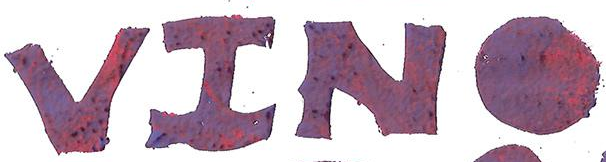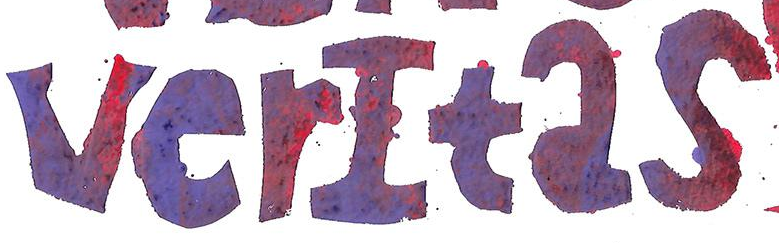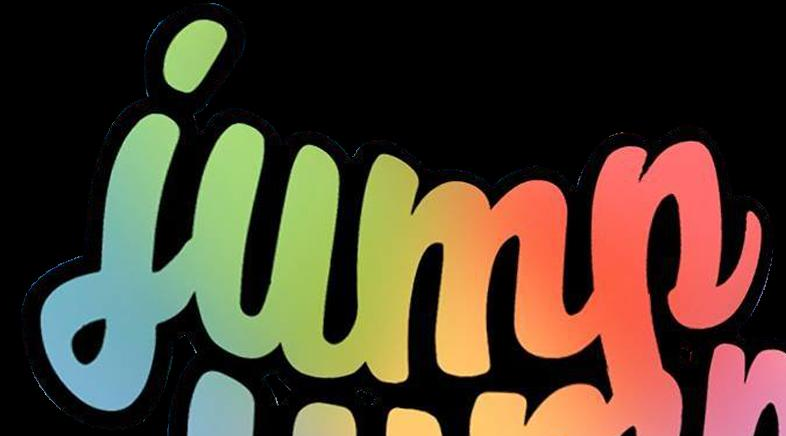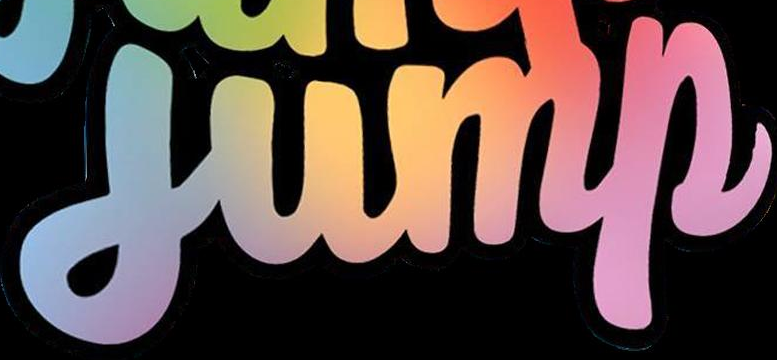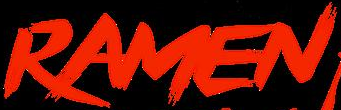What text is displayed in these images sequentially, separated by a semicolon? VINO; verItas; jump; jump; RAMEN 